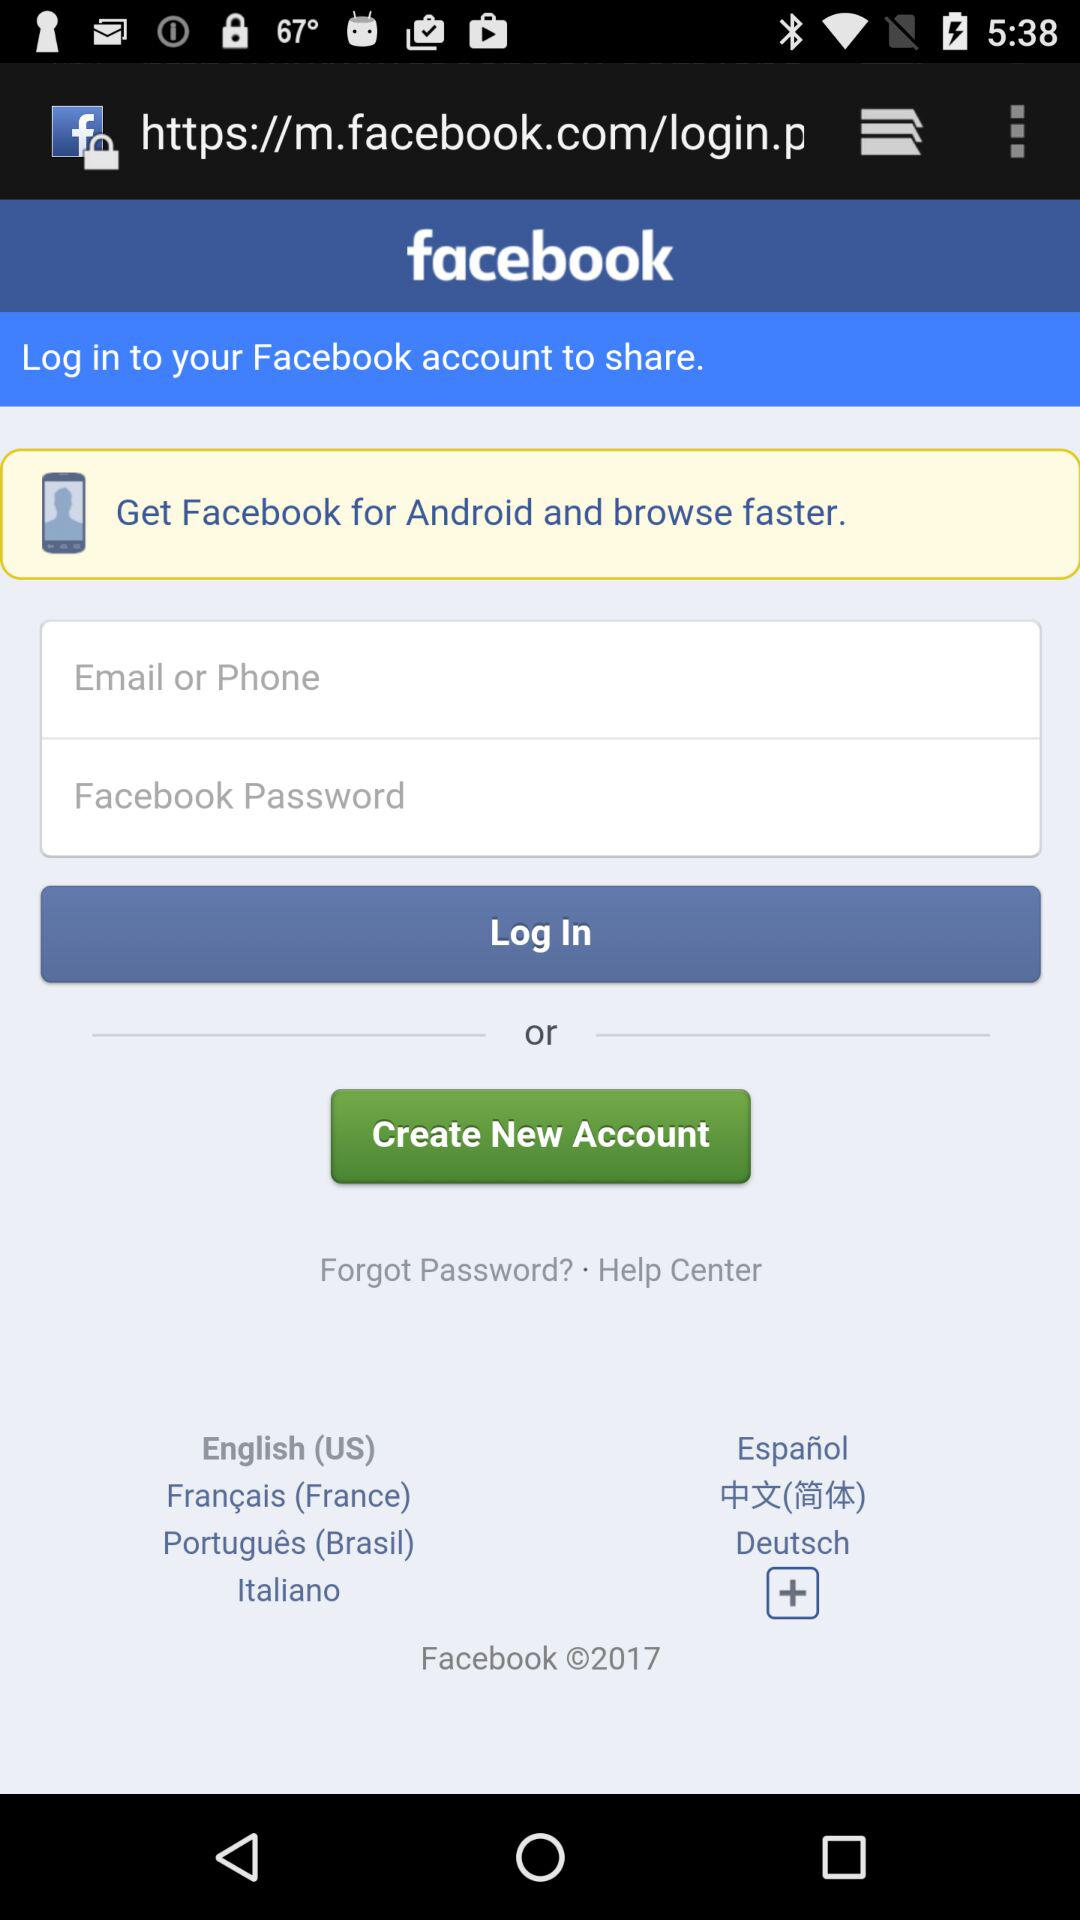What is the application name? The application name is "facebook". 